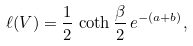<formula> <loc_0><loc_0><loc_500><loc_500>\ell ( V ) = \frac { 1 } { 2 } \, \coth \frac { \beta } { 2 } \, e ^ { - ( a + b ) } ,</formula> 